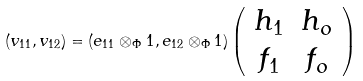Convert formula to latex. <formula><loc_0><loc_0><loc_500><loc_500>( v _ { 1 1 } , v _ { 1 2 } ) = ( e _ { 1 1 } \otimes _ { \Phi } 1 , e _ { 1 2 } \otimes _ { \Phi } 1 ) \left ( \begin{array} { c c } h _ { 1 } & h _ { o } \\ f _ { 1 } & f _ { o } \\ \end{array} \right )</formula> 